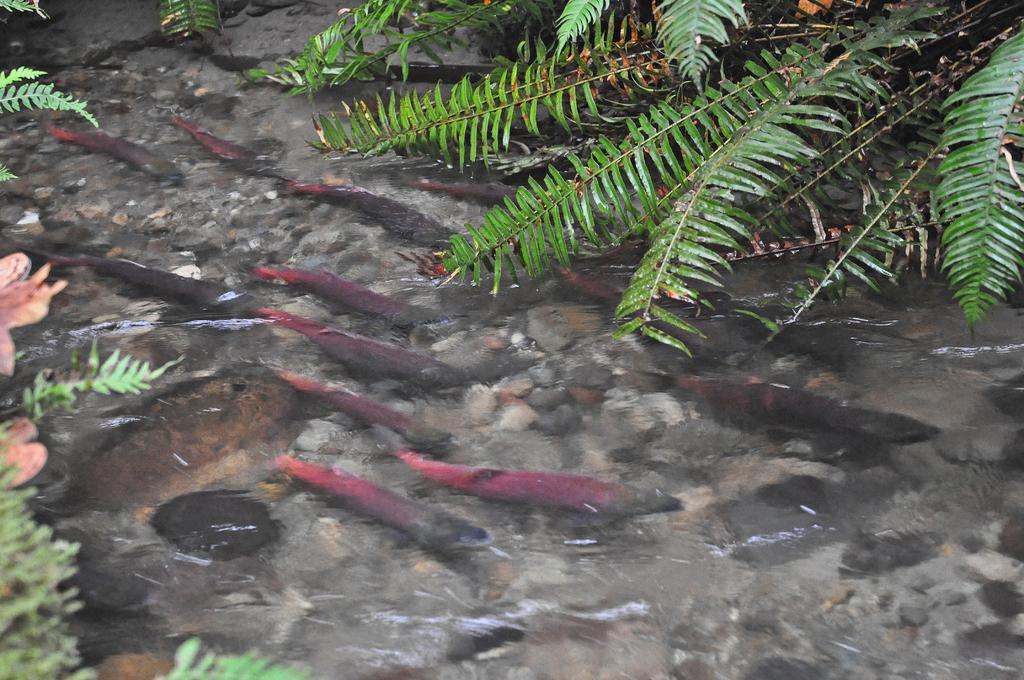What type of animals can be seen in the image? There are fishes in the water in the image. What else can be seen in the image besides the fishes? There are plants visible in the image. What type of wound can be seen on the fish in the image? There is no wound visible on any fish in the image, as the fishes appear to be healthy and swimming in the water. 